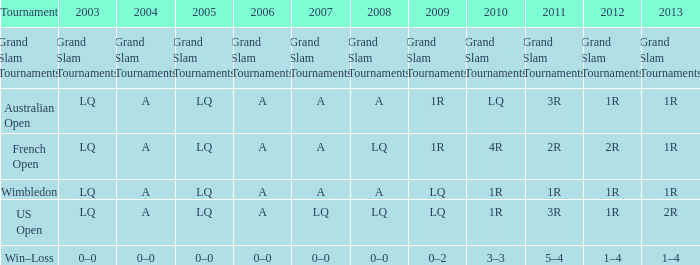In which year does 1r correspond to 2011? A. 